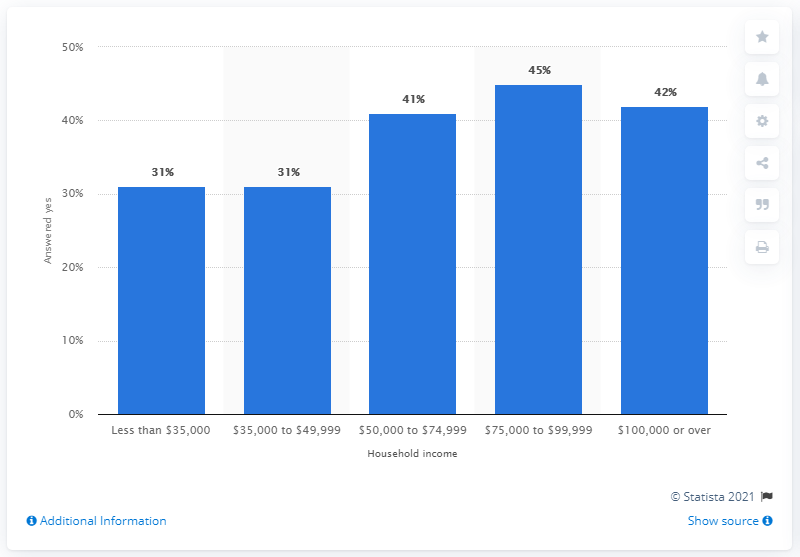What can you infer about the possible reasons for the variation in Major League Baseball interest across different income brackets? Based on the chart, one might infer that disposable income could influence interest in Major League Baseball, as attending games and purchasing related merchandise often involves extra spending. The higher interest in the upper-middle-income brackets could be due to greater financial flexibility to engage with the sport. However, without additional context or data, these inferences are speculative.  Could there be any other factors besides income that might affect the level of interest in Major League Baseball? Certainly, factors such as geographic location, cultural influence, availability of local teams, and personal or family traditions might also play significant roles in determining interest in Major League Baseball. Income is just one of many factors that could impact a person's engagement with the sport. 